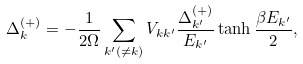<formula> <loc_0><loc_0><loc_500><loc_500>\Delta _ { k } ^ { ( + ) } = - \frac { 1 } { 2 \Omega } \sum _ { { k } ^ { \prime } ( \neq { k } ) } V _ { { k } { k } ^ { \prime } } \frac { \Delta _ { { k } ^ { \prime } } ^ { ( + ) } } { E _ { { k } ^ { \prime } } } \tanh \frac { \beta E _ { { k } ^ { \prime } } } { 2 } ,</formula> 